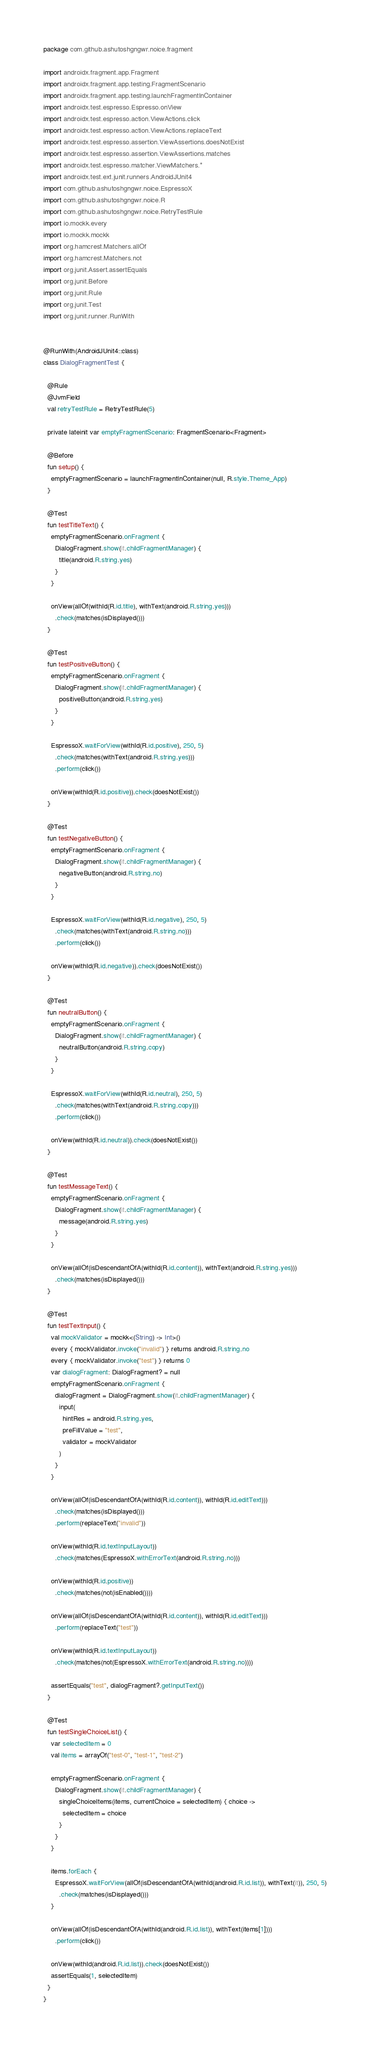<code> <loc_0><loc_0><loc_500><loc_500><_Kotlin_>package com.github.ashutoshgngwr.noice.fragment

import androidx.fragment.app.Fragment
import androidx.fragment.app.testing.FragmentScenario
import androidx.fragment.app.testing.launchFragmentInContainer
import androidx.test.espresso.Espresso.onView
import androidx.test.espresso.action.ViewActions.click
import androidx.test.espresso.action.ViewActions.replaceText
import androidx.test.espresso.assertion.ViewAssertions.doesNotExist
import androidx.test.espresso.assertion.ViewAssertions.matches
import androidx.test.espresso.matcher.ViewMatchers.*
import androidx.test.ext.junit.runners.AndroidJUnit4
import com.github.ashutoshgngwr.noice.EspressoX
import com.github.ashutoshgngwr.noice.R
import com.github.ashutoshgngwr.noice.RetryTestRule
import io.mockk.every
import io.mockk.mockk
import org.hamcrest.Matchers.allOf
import org.hamcrest.Matchers.not
import org.junit.Assert.assertEquals
import org.junit.Before
import org.junit.Rule
import org.junit.Test
import org.junit.runner.RunWith


@RunWith(AndroidJUnit4::class)
class DialogFragmentTest {

  @Rule
  @JvmField
  val retryTestRule = RetryTestRule(5)

  private lateinit var emptyFragmentScenario: FragmentScenario<Fragment>

  @Before
  fun setup() {
    emptyFragmentScenario = launchFragmentInContainer(null, R.style.Theme_App)
  }

  @Test
  fun testTitleText() {
    emptyFragmentScenario.onFragment {
      DialogFragment.show(it.childFragmentManager) {
        title(android.R.string.yes)
      }
    }

    onView(allOf(withId(R.id.title), withText(android.R.string.yes)))
      .check(matches(isDisplayed()))
  }

  @Test
  fun testPositiveButton() {
    emptyFragmentScenario.onFragment {
      DialogFragment.show(it.childFragmentManager) {
        positiveButton(android.R.string.yes)
      }
    }

    EspressoX.waitForView(withId(R.id.positive), 250, 5)
      .check(matches(withText(android.R.string.yes)))
      .perform(click())

    onView(withId(R.id.positive)).check(doesNotExist())
  }

  @Test
  fun testNegativeButton() {
    emptyFragmentScenario.onFragment {
      DialogFragment.show(it.childFragmentManager) {
        negativeButton(android.R.string.no)
      }
    }

    EspressoX.waitForView(withId(R.id.negative), 250, 5)
      .check(matches(withText(android.R.string.no)))
      .perform(click())

    onView(withId(R.id.negative)).check(doesNotExist())
  }

  @Test
  fun neutralButton() {
    emptyFragmentScenario.onFragment {
      DialogFragment.show(it.childFragmentManager) {
        neutralButton(android.R.string.copy)
      }
    }

    EspressoX.waitForView(withId(R.id.neutral), 250, 5)
      .check(matches(withText(android.R.string.copy)))
      .perform(click())

    onView(withId(R.id.neutral)).check(doesNotExist())
  }

  @Test
  fun testMessageText() {
    emptyFragmentScenario.onFragment {
      DialogFragment.show(it.childFragmentManager) {
        message(android.R.string.yes)
      }
    }

    onView(allOf(isDescendantOfA(withId(R.id.content)), withText(android.R.string.yes)))
      .check(matches(isDisplayed()))
  }

  @Test
  fun testTextInput() {
    val mockValidator = mockk<(String) -> Int>()
    every { mockValidator.invoke("invalid") } returns android.R.string.no
    every { mockValidator.invoke("test") } returns 0
    var dialogFragment: DialogFragment? = null
    emptyFragmentScenario.onFragment {
      dialogFragment = DialogFragment.show(it.childFragmentManager) {
        input(
          hintRes = android.R.string.yes,
          preFillValue = "test",
          validator = mockValidator
        )
      }
    }

    onView(allOf(isDescendantOfA(withId(R.id.content)), withId(R.id.editText)))
      .check(matches(isDisplayed()))
      .perform(replaceText("invalid"))

    onView(withId(R.id.textInputLayout))
      .check(matches(EspressoX.withErrorText(android.R.string.no)))

    onView(withId(R.id.positive))
      .check(matches(not(isEnabled())))

    onView(allOf(isDescendantOfA(withId(R.id.content)), withId(R.id.editText)))
      .perform(replaceText("test"))

    onView(withId(R.id.textInputLayout))
      .check(matches(not(EspressoX.withErrorText(android.R.string.no))))

    assertEquals("test", dialogFragment?.getInputText())
  }

  @Test
  fun testSingleChoiceList() {
    var selectedItem = 0
    val items = arrayOf("test-0", "test-1", "test-2")

    emptyFragmentScenario.onFragment {
      DialogFragment.show(it.childFragmentManager) {
        singleChoiceItems(items, currentChoice = selectedItem) { choice ->
          selectedItem = choice
        }
      }
    }

    items.forEach {
      EspressoX.waitForView(allOf(isDescendantOfA(withId(android.R.id.list)), withText(it)), 250, 5)
        .check(matches(isDisplayed()))
    }

    onView(allOf(isDescendantOfA(withId(android.R.id.list)), withText(items[1])))
      .perform(click())

    onView(withId(android.R.id.list)).check(doesNotExist())
    assertEquals(1, selectedItem)
  }
}
</code> 